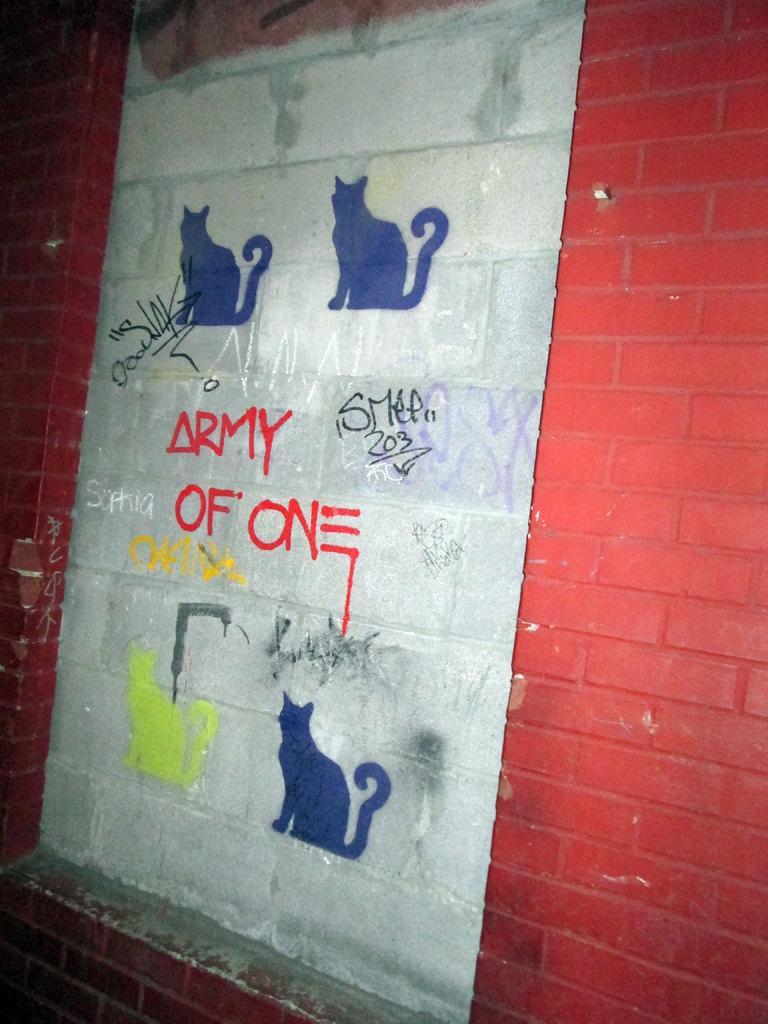How would you summarize this image in a sentence or two? On a wall there is a painting of cats and something is written. There is red paint on either sides. 